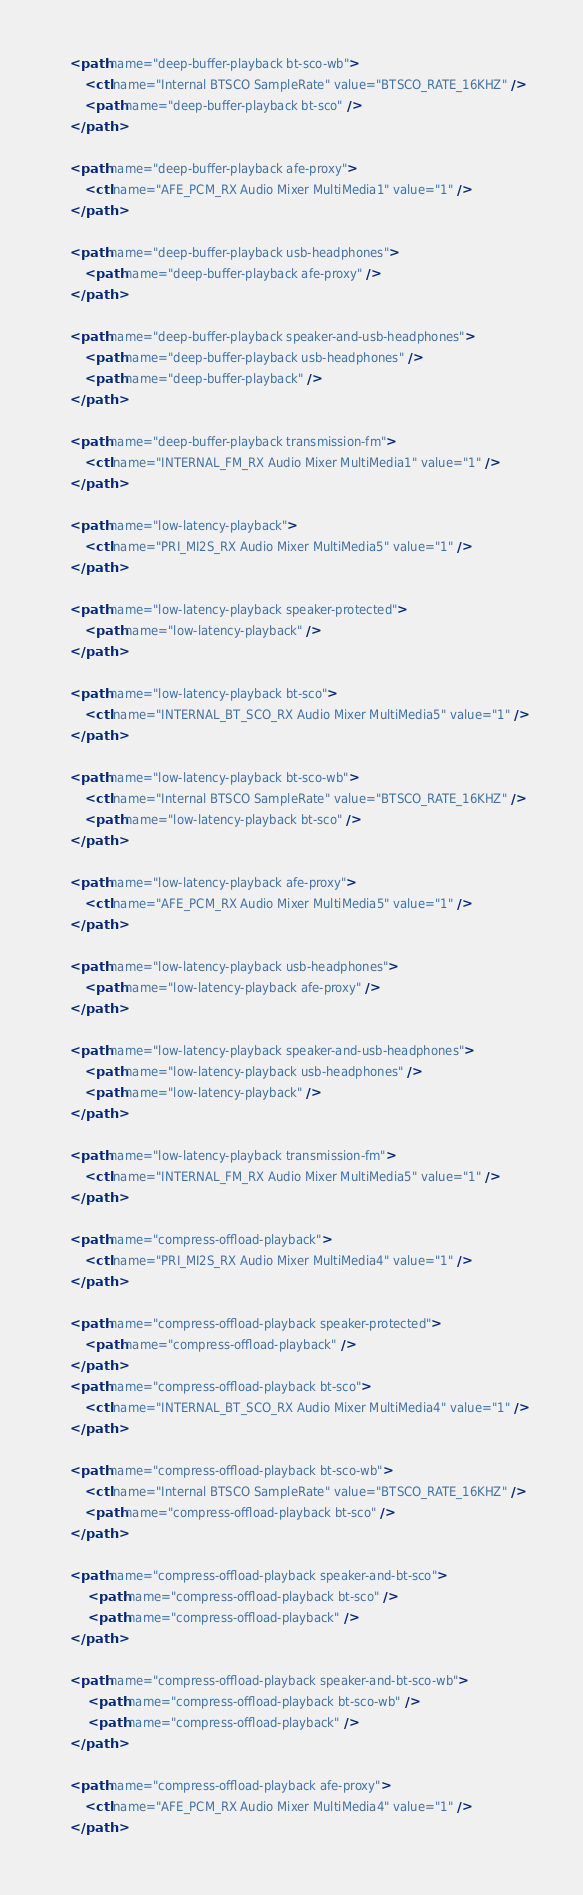<code> <loc_0><loc_0><loc_500><loc_500><_XML_>
    <path name="deep-buffer-playback bt-sco-wb">
        <ctl name="Internal BTSCO SampleRate" value="BTSCO_RATE_16KHZ" />
        <path name="deep-buffer-playback bt-sco" />
    </path>

    <path name="deep-buffer-playback afe-proxy">
        <ctl name="AFE_PCM_RX Audio Mixer MultiMedia1" value="1" />
    </path>

    <path name="deep-buffer-playback usb-headphones">
        <path name="deep-buffer-playback afe-proxy" />
    </path>

    <path name="deep-buffer-playback speaker-and-usb-headphones">
        <path name="deep-buffer-playback usb-headphones" />
        <path name="deep-buffer-playback" />
    </path>

    <path name="deep-buffer-playback transmission-fm">
        <ctl name="INTERNAL_FM_RX Audio Mixer MultiMedia1" value="1" />
    </path>

    <path name="low-latency-playback">
        <ctl name="PRI_MI2S_RX Audio Mixer MultiMedia5" value="1" />
    </path>

    <path name="low-latency-playback speaker-protected">
        <path name="low-latency-playback" />
    </path>

    <path name="low-latency-playback bt-sco">
        <ctl name="INTERNAL_BT_SCO_RX Audio Mixer MultiMedia5" value="1" />
    </path>

    <path name="low-latency-playback bt-sco-wb">
        <ctl name="Internal BTSCO SampleRate" value="BTSCO_RATE_16KHZ" />
        <path name="low-latency-playback bt-sco" />
    </path>

    <path name="low-latency-playback afe-proxy">
        <ctl name="AFE_PCM_RX Audio Mixer MultiMedia5" value="1" />
    </path>

    <path name="low-latency-playback usb-headphones">
        <path name="low-latency-playback afe-proxy" />
    </path>

    <path name="low-latency-playback speaker-and-usb-headphones">
        <path name="low-latency-playback usb-headphones" />
        <path name="low-latency-playback" />
    </path>

    <path name="low-latency-playback transmission-fm">
        <ctl name="INTERNAL_FM_RX Audio Mixer MultiMedia5" value="1" />
    </path>

    <path name="compress-offload-playback">
        <ctl name="PRI_MI2S_RX Audio Mixer MultiMedia4" value="1" />
    </path>

    <path name="compress-offload-playback speaker-protected">
        <path name="compress-offload-playback" />
    </path>
    <path name="compress-offload-playback bt-sco">
        <ctl name="INTERNAL_BT_SCO_RX Audio Mixer MultiMedia4" value="1" />
    </path>

    <path name="compress-offload-playback bt-sco-wb">
        <ctl name="Internal BTSCO SampleRate" value="BTSCO_RATE_16KHZ" />
        <path name="compress-offload-playback bt-sco" />
    </path>

    <path name="compress-offload-playback speaker-and-bt-sco">
         <path name="compress-offload-playback bt-sco" />
         <path name="compress-offload-playback" />
    </path>

    <path name="compress-offload-playback speaker-and-bt-sco-wb">
         <path name="compress-offload-playback bt-sco-wb" />
         <path name="compress-offload-playback" />
    </path>

    <path name="compress-offload-playback afe-proxy">
        <ctl name="AFE_PCM_RX Audio Mixer MultiMedia4" value="1" />
    </path>
</code> 